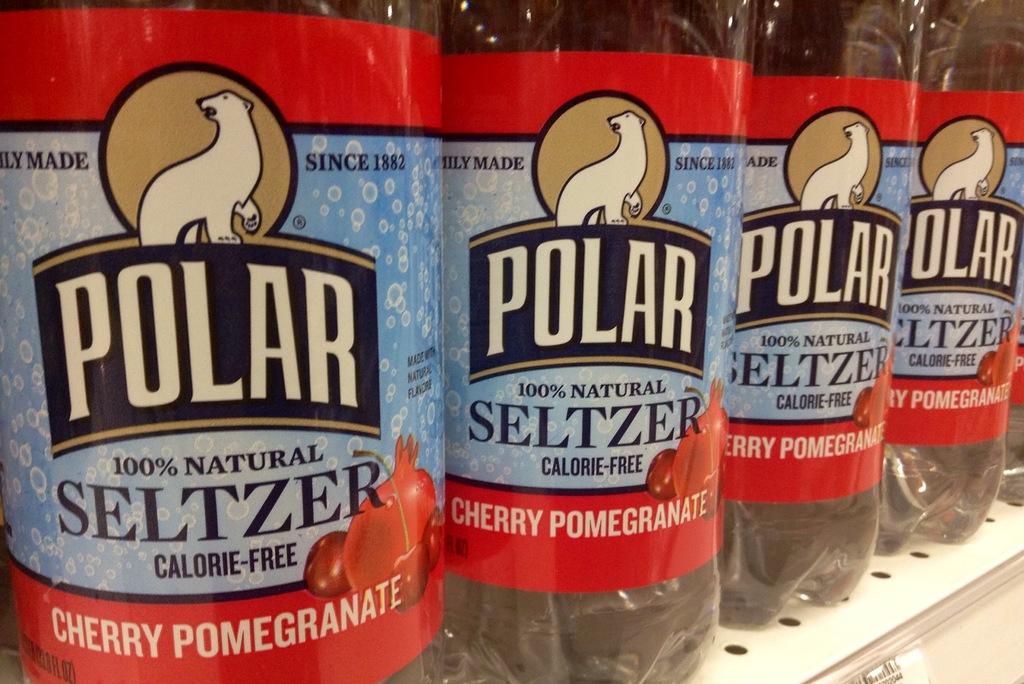What flavor is this selzter water?
Give a very brief answer. Cherry pomegranate. What is the brand of seltzer?
Offer a very short reply. Polar. 